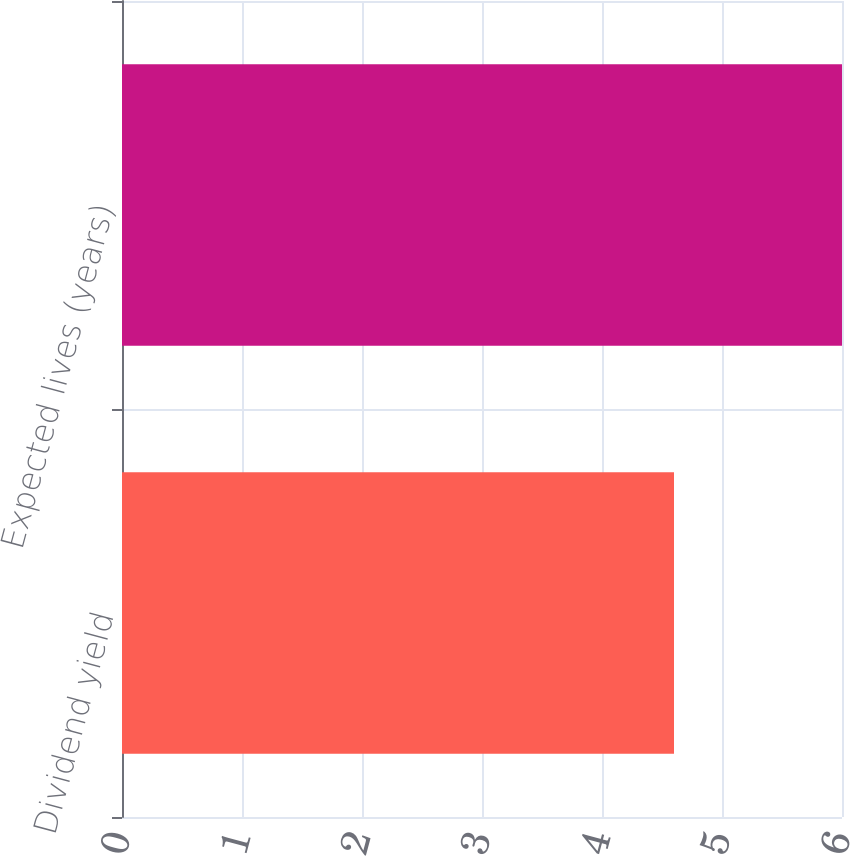Convert chart. <chart><loc_0><loc_0><loc_500><loc_500><bar_chart><fcel>Dividend yield<fcel>Expected lives (years)<nl><fcel>4.6<fcel>6<nl></chart> 